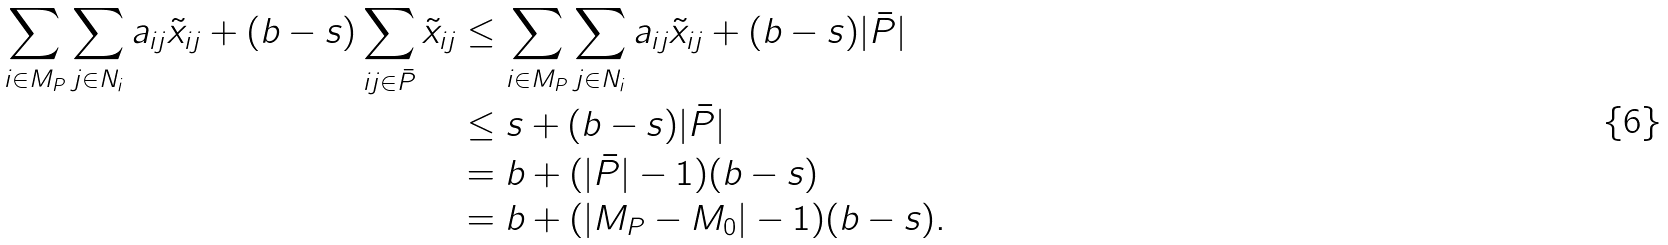Convert formula to latex. <formula><loc_0><loc_0><loc_500><loc_500>\sum _ { i \in M _ { P } } \sum _ { j \in N _ { i } } a _ { i j } \tilde { x } _ { i j } + ( b - s ) \sum _ { i j \in \bar { P } } \tilde { x } _ { i j } & \leq \sum _ { i \in M _ { P } } \sum _ { j \in N _ { i } } a _ { i j } \tilde { x } _ { i j } + ( b - s ) | \bar { P } | \\ & \leq s + ( b - s ) | \bar { P } | \\ & = b + ( | \bar { P } | - 1 ) ( b - s ) \\ & = b + ( | M _ { P } - M _ { 0 } | - 1 ) ( b - s ) .</formula> 